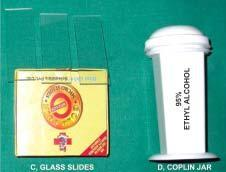s m phase required for transcutaneous fnac?
Answer the question using a single word or phrase. No 